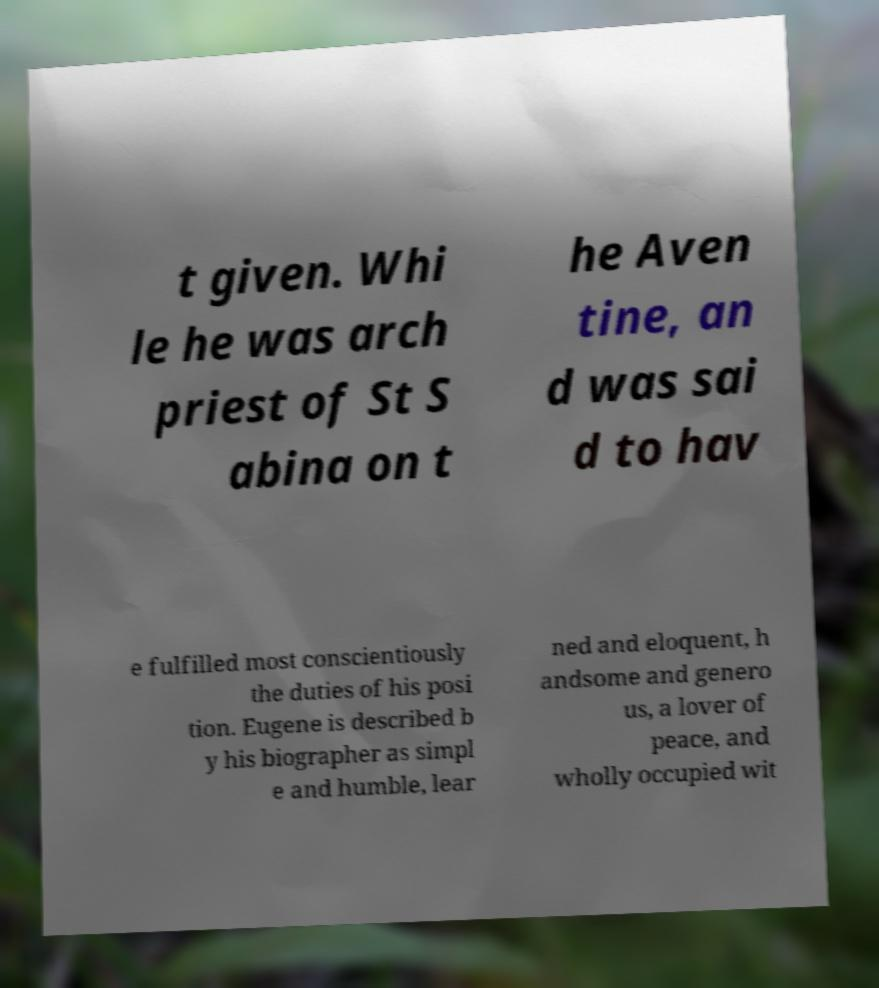There's text embedded in this image that I need extracted. Can you transcribe it verbatim? t given. Whi le he was arch priest of St S abina on t he Aven tine, an d was sai d to hav e fulfilled most conscientiously the duties of his posi tion. Eugene is described b y his biographer as simpl e and humble, lear ned and eloquent, h andsome and genero us, a lover of peace, and wholly occupied wit 